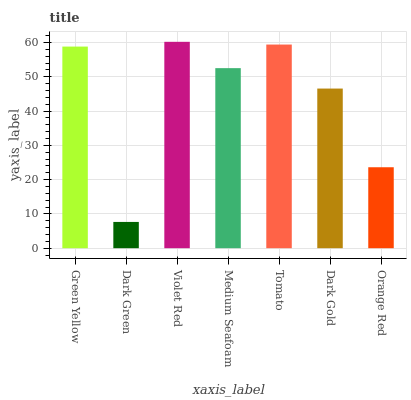Is Violet Red the minimum?
Answer yes or no. No. Is Dark Green the maximum?
Answer yes or no. No. Is Violet Red greater than Dark Green?
Answer yes or no. Yes. Is Dark Green less than Violet Red?
Answer yes or no. Yes. Is Dark Green greater than Violet Red?
Answer yes or no. No. Is Violet Red less than Dark Green?
Answer yes or no. No. Is Medium Seafoam the high median?
Answer yes or no. Yes. Is Medium Seafoam the low median?
Answer yes or no. Yes. Is Green Yellow the high median?
Answer yes or no. No. Is Violet Red the low median?
Answer yes or no. No. 